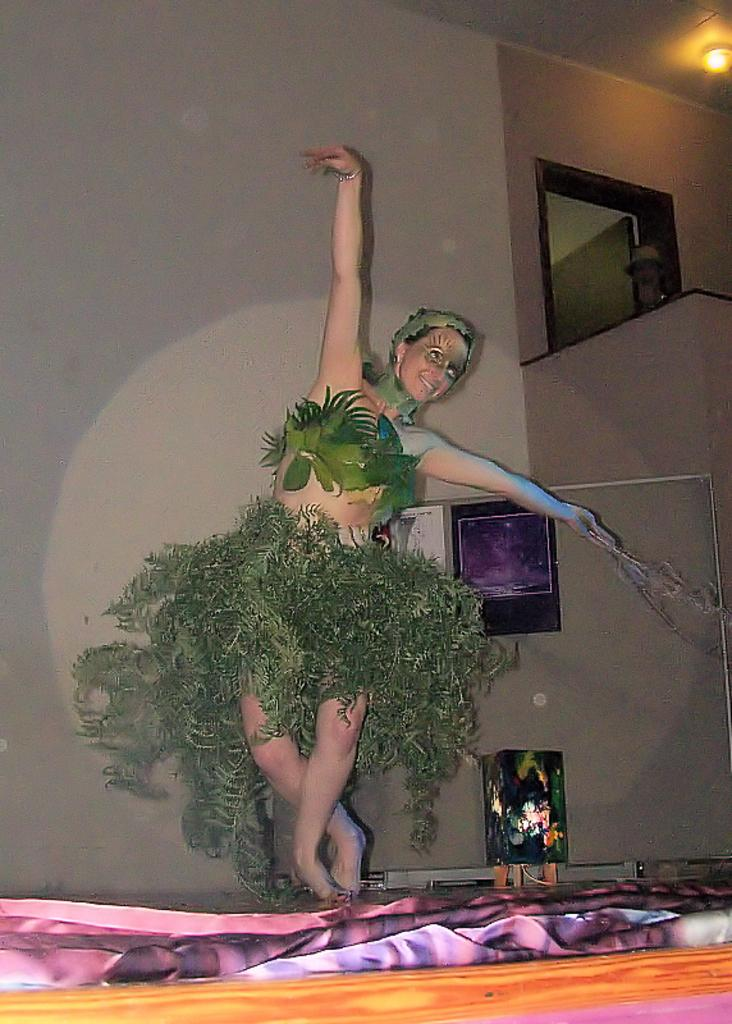What is the person in the image wearing? The person in the image is wearing a fancy dress. What can be seen on the wall in the image? There are papers on the wall in the image. What architectural feature is present in the image? There is a door in the image. What source of illumination is visible in the image? There is a light in the image. Can you describe any other objects present in the image? There are some other objects in the image, but their specific details are not mentioned in the provided facts. What type of vest is the minister wearing in the image? There is no minister or vest present in the image. How much money can be seen in the image? There is no money visible in the image. 